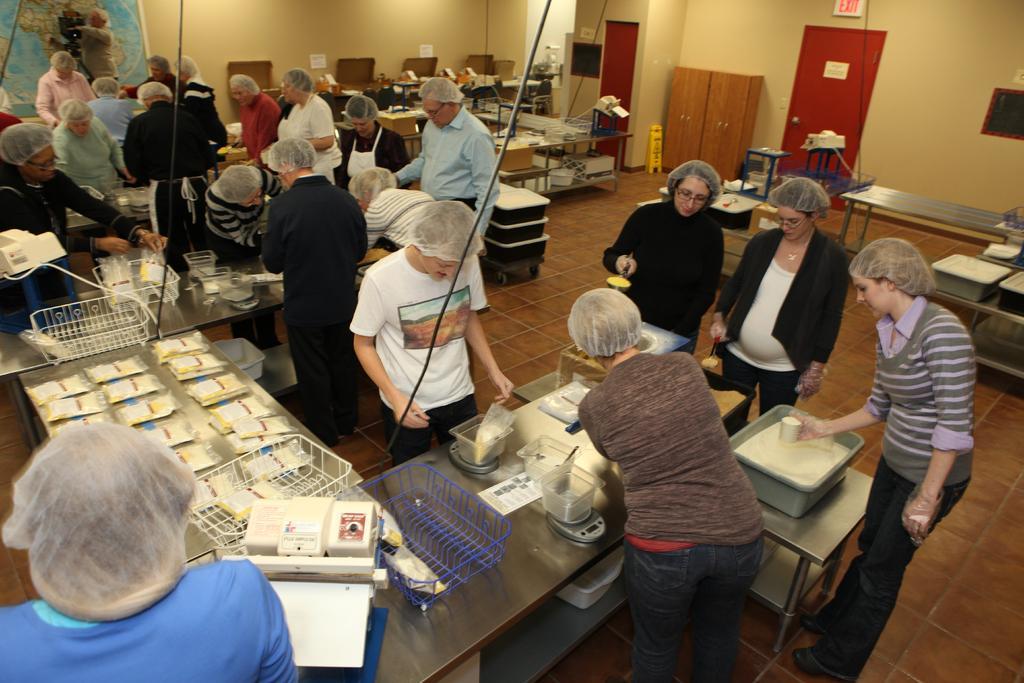In one or two sentences, can you explain what this image depicts? There are many people in this room. Some of them are packing food. Some of them are arranging them. Some of them are weighing them. In the background there is a cup board, door and a wall here. 